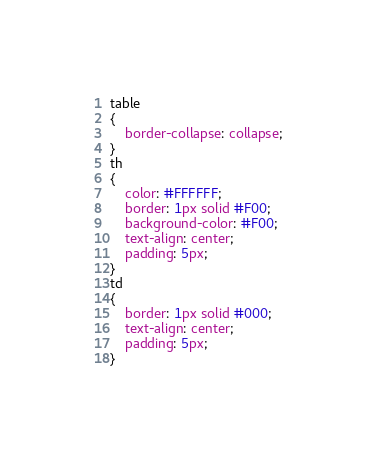Convert code to text. <code><loc_0><loc_0><loc_500><loc_500><_CSS_>table
{
    border-collapse: collapse; 
}
th
{
    color: #FFFFFF;
    border: 1px solid #F00;
    background-color: #F00;
    text-align: center;
    padding: 5px;
}
td
{
    border: 1px solid #000;
    text-align: center;
    padding: 5px;
}</code> 